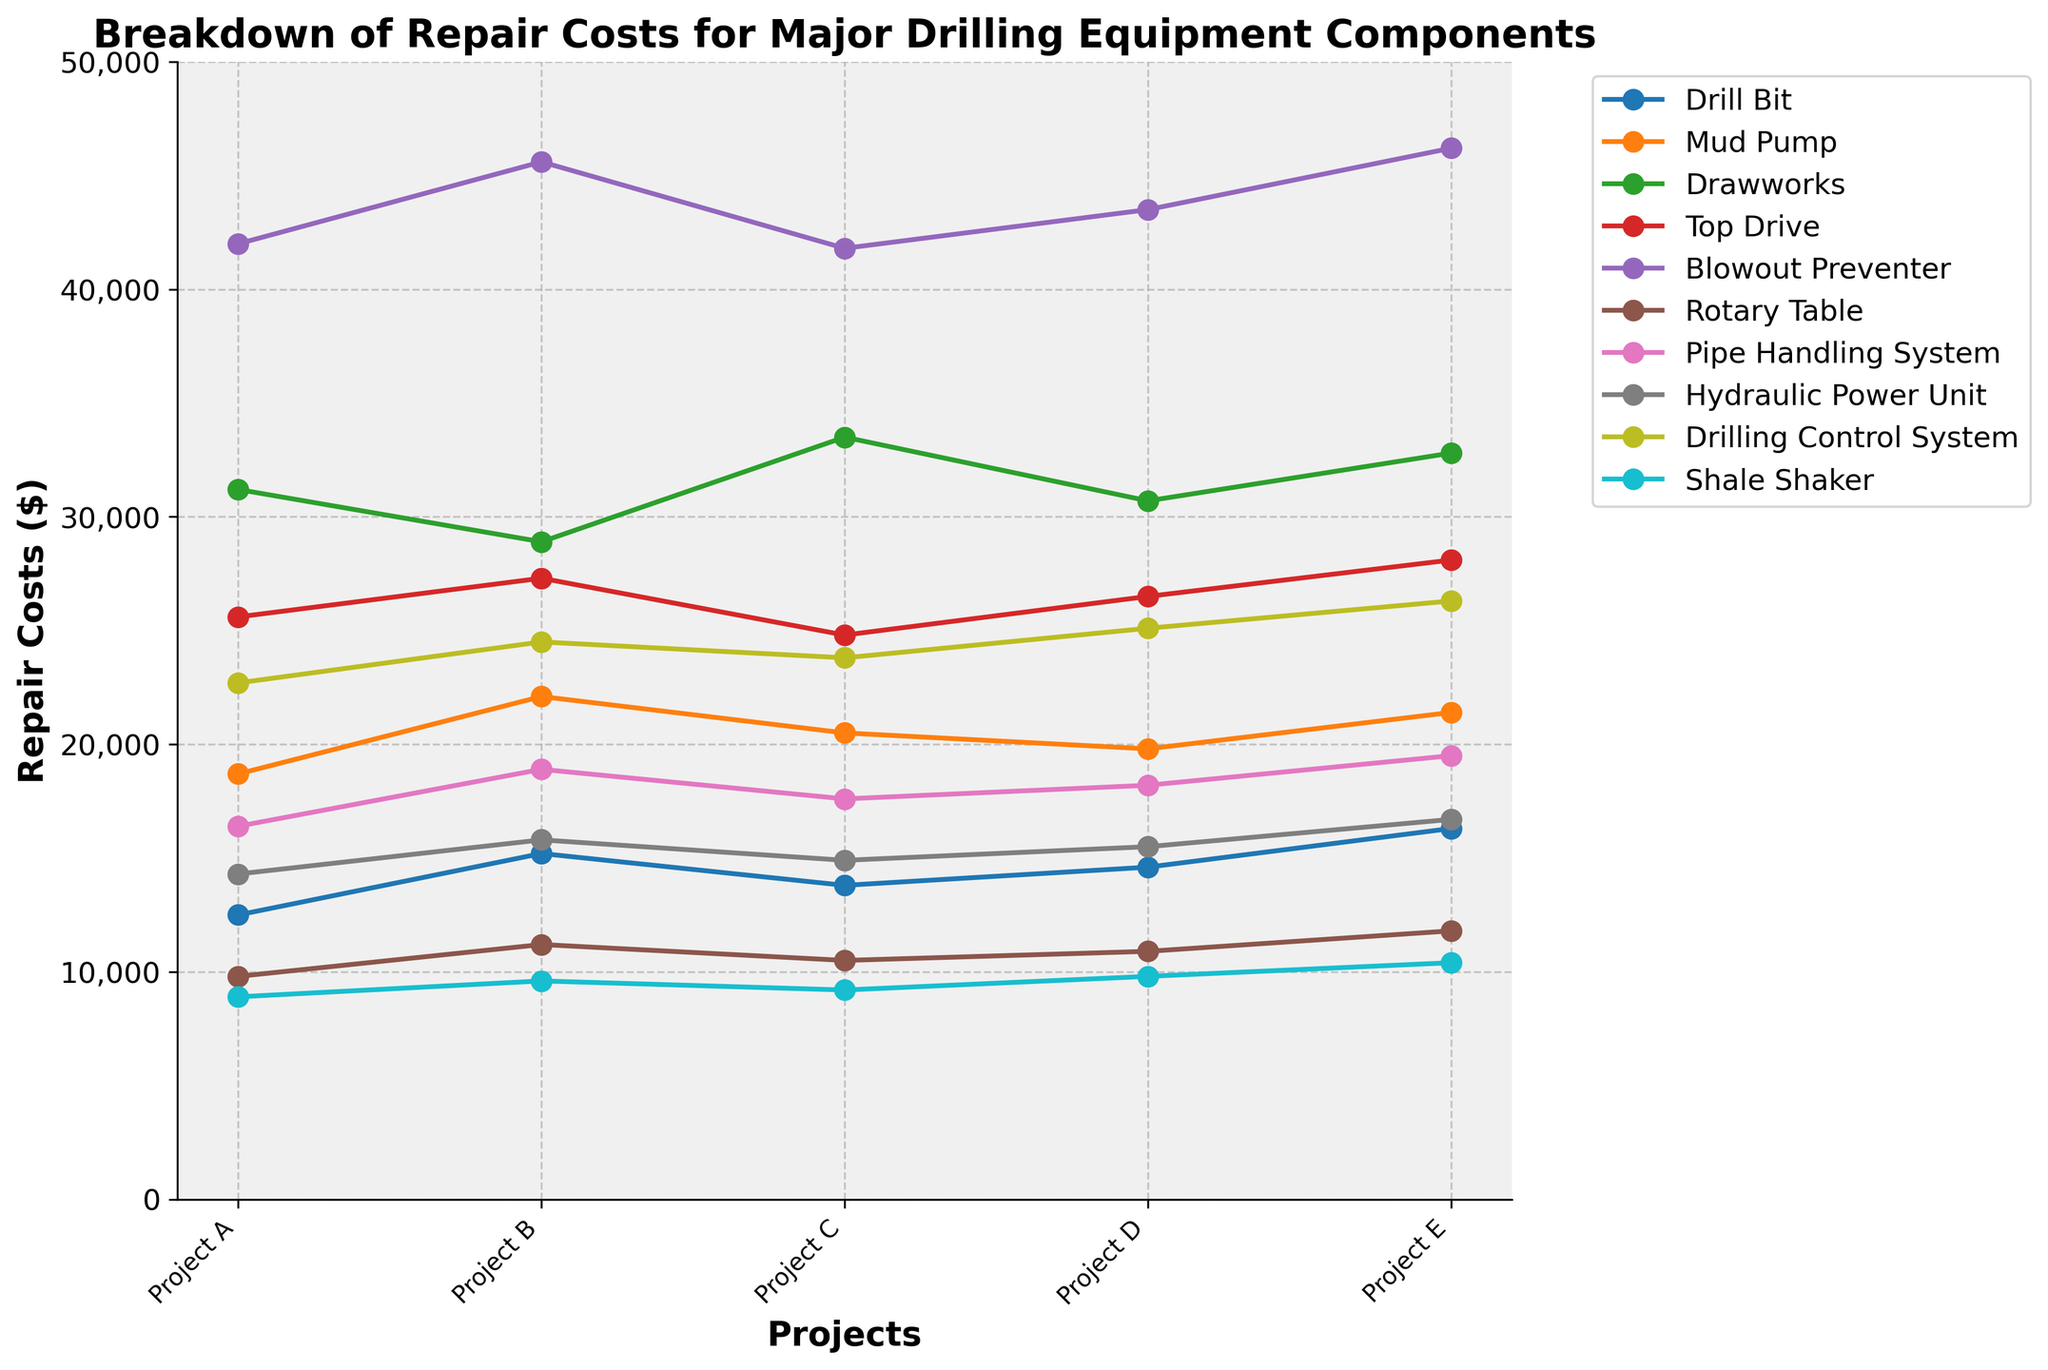What's the total repair cost for the Blowout Preventer across all projects? Add the repair costs from Project A to Project E for the Blowout Preventer: 42000 + 45600 + 41800 + 43500 + 46200 = 219100
Answer: 219100 Which component has the highest repair cost in Project B? Compare the values for each component in Project B. The Blowout Preventer has the highest cost of 45600
Answer: Blowout Preventer Does the Mud Pump's repair cost in Project D exceed that of the Top Drive in the same project? Check the values for Mud Pump and Top Drive in Project D: Mud Pump (19800) is less than Top Drive (26500)
Answer: No What's the average repair cost for the Shale Shaker across all projects? Add the costs for Shale Shaker across all projects and divide by the number of projects: (8900 + 9600 + 9200 + 9800 + 10400) / 5 = 9590
Answer: 9590 Which component shows the greatest increase in repair cost from Project A to Project E? Compare the differences in repair costs from Project A to Project E for each component. The Blowout Preventer's cost increases the most from 42000 to 46200, an increase of 4200
Answer: Blowout Preventer Is there any project where the Drawworks' repair cost exceeds 33000? Check the values for Drawworks across all projects. In Project C, Drawworks costs 33500
Answer: Yes What is the difference in repair costs between the Hydraulic Power Unit and the Drilling Control System in Project E? Subtract the cost of the Hydraulic Power Unit from that of the Drilling Control System in Project E: 26300 - 16700 = 9600
Answer: 9600 Among Project C's data, which component has the second highest repair cost? List the costs for Project C and sort them. The Blowout Preventer is highest at 41800, and Drawworks is second at 33500
Answer: Drawworks Are the repair costs for the Drill Bit in Project A lower than those in Project D? Compare the Drill Bit's costs in Project A (12500) and Project D (14600). Yes, Project A's cost is lower
Answer: Yes 